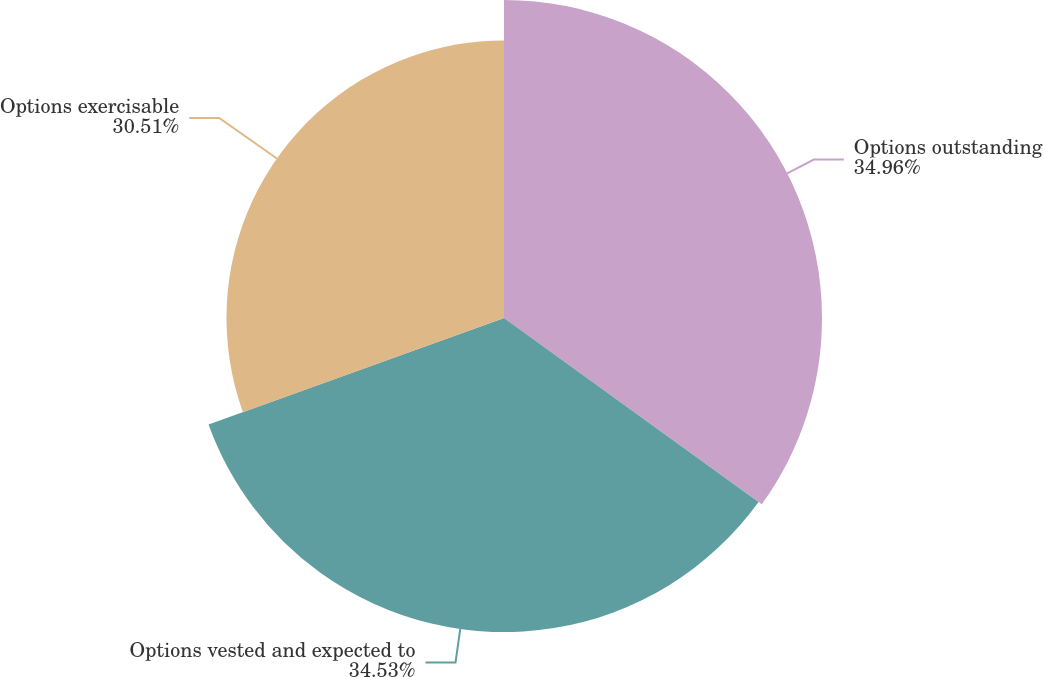Convert chart to OTSL. <chart><loc_0><loc_0><loc_500><loc_500><pie_chart><fcel>Options outstanding<fcel>Options vested and expected to<fcel>Options exercisable<nl><fcel>34.96%<fcel>34.53%<fcel>30.51%<nl></chart> 